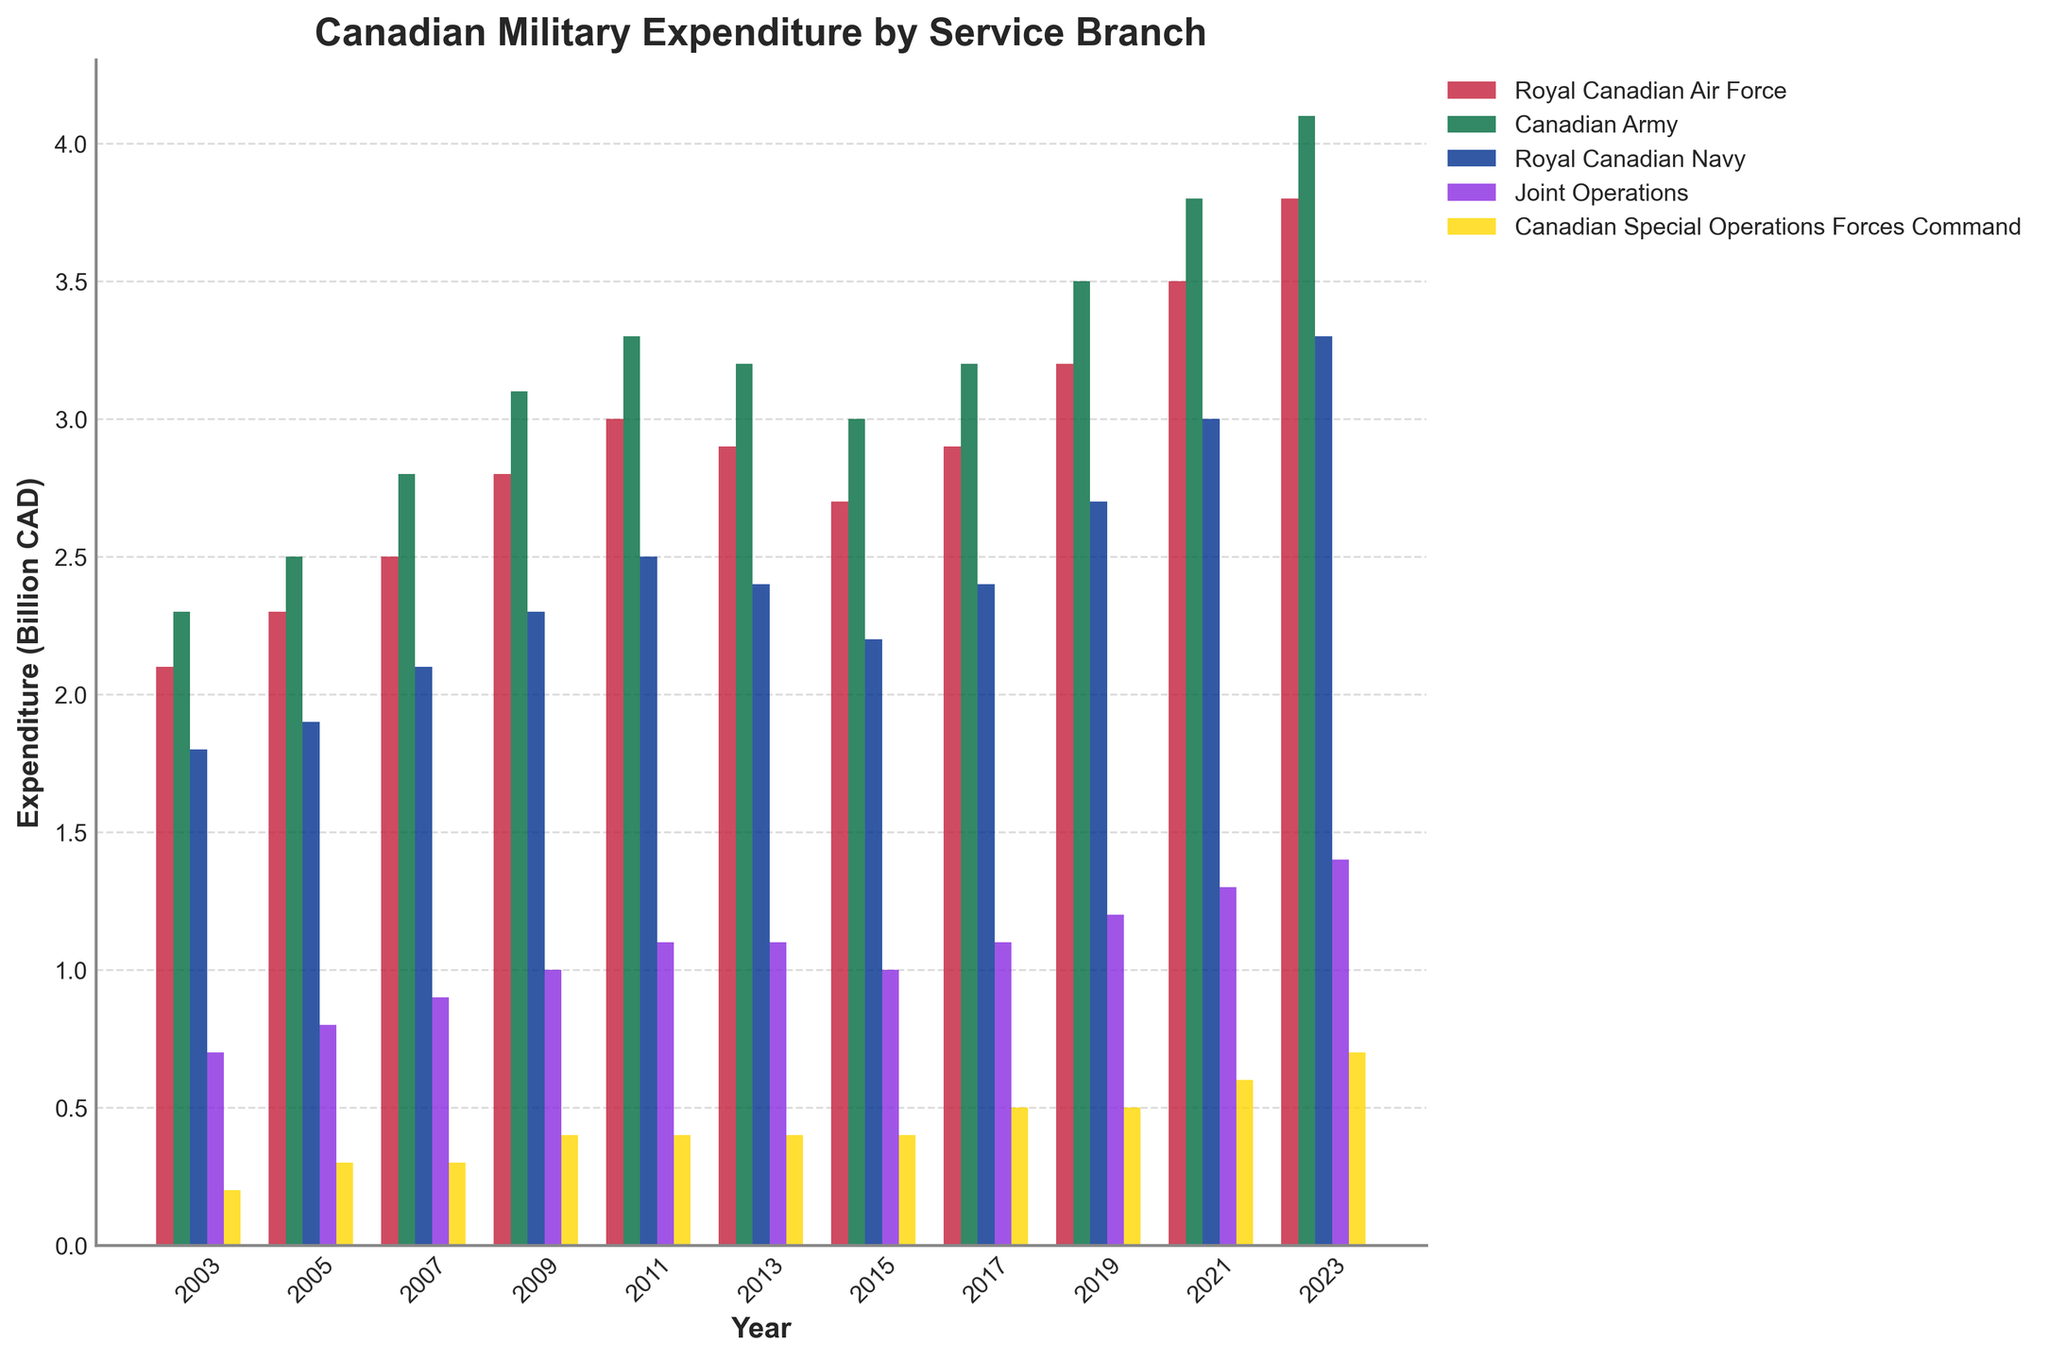what is the total military expenditure in 2023? To find the total military expenditure in 2023, sum the expenditures of all service branches for that year: 3.8 (RCAF) + 4.1 (Canadian Army) + 3.3 (RCN) + 1.4 (Joint Operations) + 0.7 (CANSOFCOM) = 13.3 billion CAD
Answer: 13.3 billion CAD Which branch had the highest increase in expenditure from 2003 to 2023? Subtract the expenditure in 2003 from the expenditure in 2023 for each branch: RCAF: 3.8 - 2.1 = 1.7; Canadian Army: 4.1 - 2.3 = 1.8; RCN: 3.3 - 1.8 = 1.5; Joint Operations: 1.4 - 0.7 = 0.7; CANSOFCOM: 0.7 - 0.2 = 0.5. The Canadian Army had the highest increase.
Answer: Canadian Army In which year did the Royal Canadian Air Force and the Royal Canadian Navy have similar expenditures? Compare the expenditures for each year: 2011 (RCAF: 3.0, RCN: 2.5), 2013 (RCAF: 2.9, RCN: 2.4), 2015 (RCAF: 2.7, RCN: 2.2), etc. The closest year appears to be 2011 with expenditures of 3.0 and 2.5 respectively.
Answer: 2011 How does the expenditure of the Royal Canadian Navy in 2023 compare to the Royal Canadian Air Force in 2019? The RCN expenditure in 2023 is 3.3 billion CAD, and the RCAF expenditure in 2019 is 3.2 billion CAD. Compare these values: 3.3 > 3.2.
Answer: RCN expenditure in 2023 is higher What is the average expenditure of Joint Operations from 2003 to 2023? Sum the Joint Operations expenditures for all years and divide by the number of years: (0.7 + 0.8 + 0.9 + 1.0 + 1.1 + 1.1 + 1.0 + 1.1 + 1.2 + 1.3 + 1.4) / 11 = 11.6 / 11 ≈ 1.05 billion CAD
Answer: 1.05 billion CAD Which branch consistently had the lowest expenditure over the years? Observe the expenditure values across years for each branch. CANSOFCOM has the lowest values in each year compared to other branches.
Answer: CANSOFCOM Between 2009 and 2019, which branch had the smallest difference in expenditure? Calculate the difference in expenditure for each branch from 2009 to 2019: RCAF: 3.2 - 2.8 = 0.4; Canadian Army: 3.5 - 3.1 = 0.4; RCN: 2.7 - 2.3 = 0.4; Joint Operations: 1.2 - 1.0 = 0.2; CANSOFCOM: 0.5 - 0.4 = 0.1. The smallest difference is for CANSOFCOM.
Answer: CANSOFCOM In which year did Joint Operations experience the highest expenditure relative to its previous year? Subtract each year's expenditure from the previous year's: 2005-2003 (0.8 - 0.7 = 0.1), 2007-2005 (0.9 - 0.8 = 0.1), 2009-2007 (1.0 - 0.9 = 0.1), 2011-2009 (1.1 - 1.0 = 0.1), 2013-2011 (1.1 - 1.1 = 0), 2015-2013 (1.0 - 1.1 = -0.1), 2017-2015 (1.1 - 1.0 = 0.1), 2019-2017 (1.2 - 1.1 = 0.1), 2021-2019 (1.3 - 1.2 = 0.1), 2023-2021 (1.4 - 1.3 = 0.1). All increases are equal (0.1), so no single highest relative increase.
Answer: No unique year, all increases are equal What is the expenditure pattern comparison between the Canadian Army and Royal Canadian Navy from 2003 to 2023? Calculate the annual expenditure growth for each year and compare patterns: Canadian Army shows a steady increase from 2.3 to 4.1 billion CAD, whereas the RCN shows a steady increase from 1.8 to 3.3 billion CAD. Both exhibit a generally similar trend but at different rates.
Answer: Steady increase for both, higher growth rate in the Canadian Army 